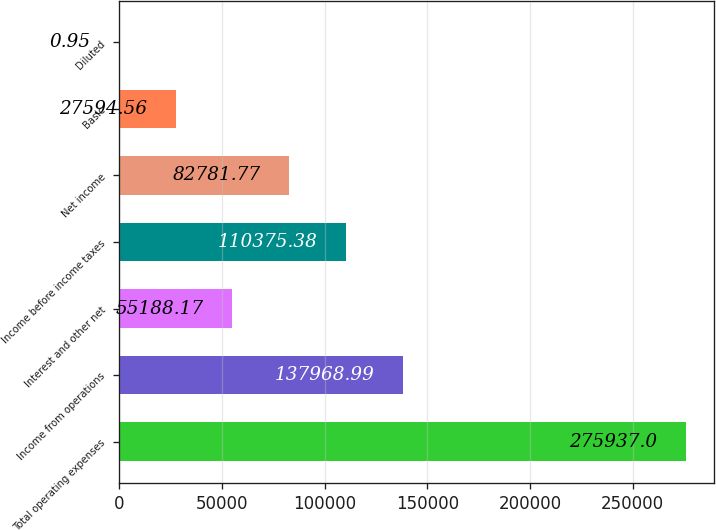Convert chart to OTSL. <chart><loc_0><loc_0><loc_500><loc_500><bar_chart><fcel>Total operating expenses<fcel>Income from operations<fcel>Interest and other net<fcel>Income before income taxes<fcel>Net income<fcel>Basic<fcel>Diluted<nl><fcel>275937<fcel>137969<fcel>55188.2<fcel>110375<fcel>82781.8<fcel>27594.6<fcel>0.95<nl></chart> 